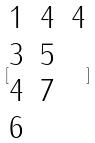Convert formula to latex. <formula><loc_0><loc_0><loc_500><loc_500>[ \begin{matrix} 1 & 4 & 4 \\ 3 & 5 \\ 4 & 7 \\ 6 \end{matrix} ]</formula> 